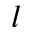<formula> <loc_0><loc_0><loc_500><loc_500>l</formula> 